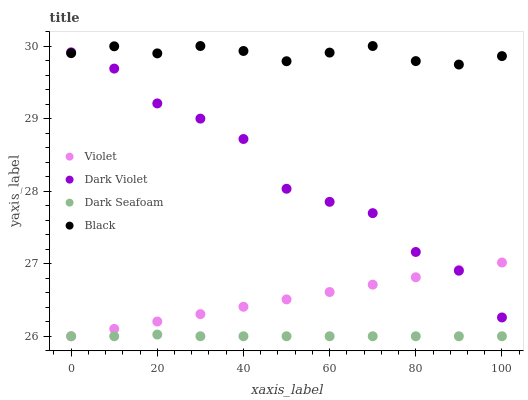Does Dark Seafoam have the minimum area under the curve?
Answer yes or no. Yes. Does Black have the maximum area under the curve?
Answer yes or no. Yes. Does Dark Violet have the minimum area under the curve?
Answer yes or no. No. Does Dark Violet have the maximum area under the curve?
Answer yes or no. No. Is Violet the smoothest?
Answer yes or no. Yes. Is Dark Violet the roughest?
Answer yes or no. Yes. Is Black the smoothest?
Answer yes or no. No. Is Black the roughest?
Answer yes or no. No. Does Dark Seafoam have the lowest value?
Answer yes or no. Yes. Does Dark Violet have the lowest value?
Answer yes or no. No. Does Black have the highest value?
Answer yes or no. Yes. Does Dark Violet have the highest value?
Answer yes or no. No. Is Dark Seafoam less than Black?
Answer yes or no. Yes. Is Black greater than Dark Seafoam?
Answer yes or no. Yes. Does Violet intersect Dark Violet?
Answer yes or no. Yes. Is Violet less than Dark Violet?
Answer yes or no. No. Is Violet greater than Dark Violet?
Answer yes or no. No. Does Dark Seafoam intersect Black?
Answer yes or no. No. 